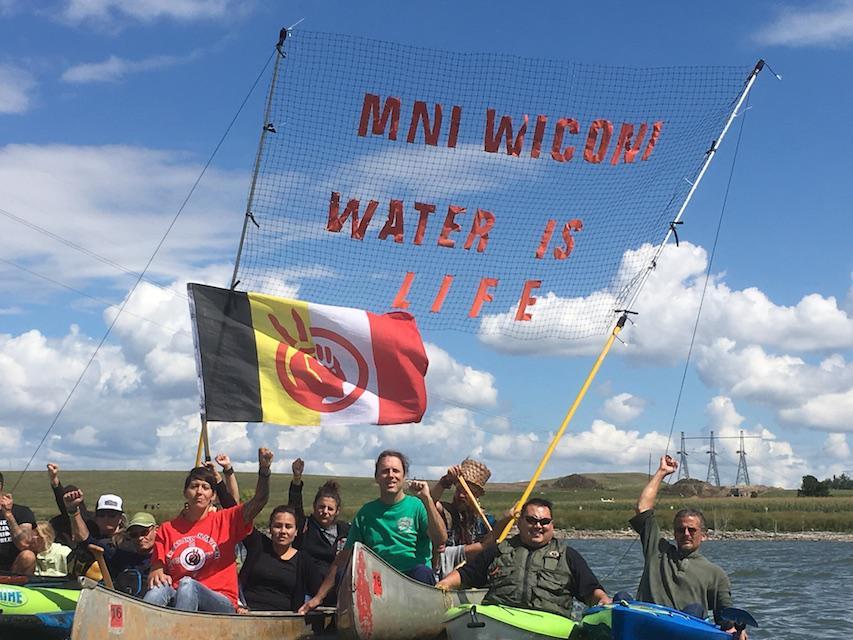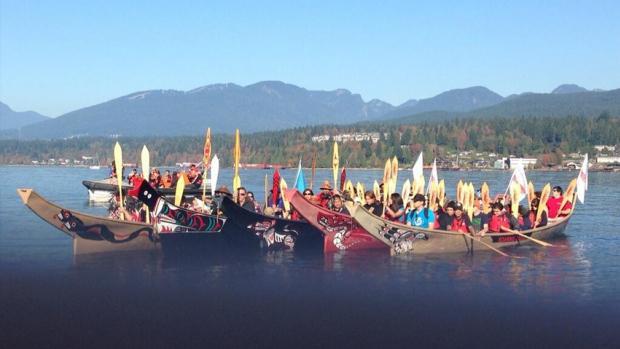The first image is the image on the left, the second image is the image on the right. Assess this claim about the two images: "One of the images shows an American Indian Movement flag with black, yellow, white, and red stripes and a red logo.". Correct or not? Answer yes or no. Yes. The first image is the image on the left, the second image is the image on the right. For the images displayed, is the sentence "Each image shows just one boat in the foreground." factually correct? Answer yes or no. No. 